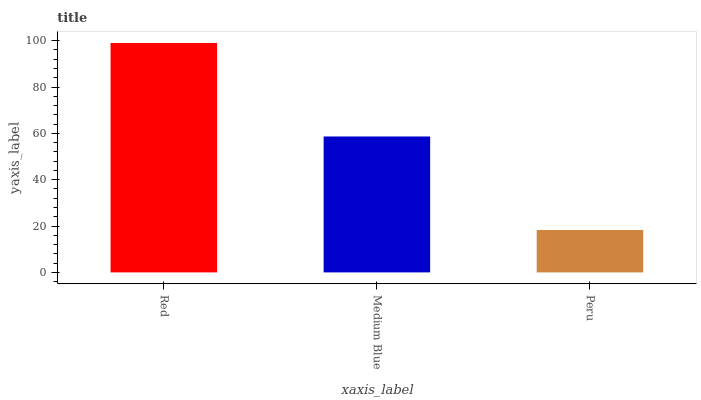Is Peru the minimum?
Answer yes or no. Yes. Is Red the maximum?
Answer yes or no. Yes. Is Medium Blue the minimum?
Answer yes or no. No. Is Medium Blue the maximum?
Answer yes or no. No. Is Red greater than Medium Blue?
Answer yes or no. Yes. Is Medium Blue less than Red?
Answer yes or no. Yes. Is Medium Blue greater than Red?
Answer yes or no. No. Is Red less than Medium Blue?
Answer yes or no. No. Is Medium Blue the high median?
Answer yes or no. Yes. Is Medium Blue the low median?
Answer yes or no. Yes. Is Peru the high median?
Answer yes or no. No. Is Peru the low median?
Answer yes or no. No. 